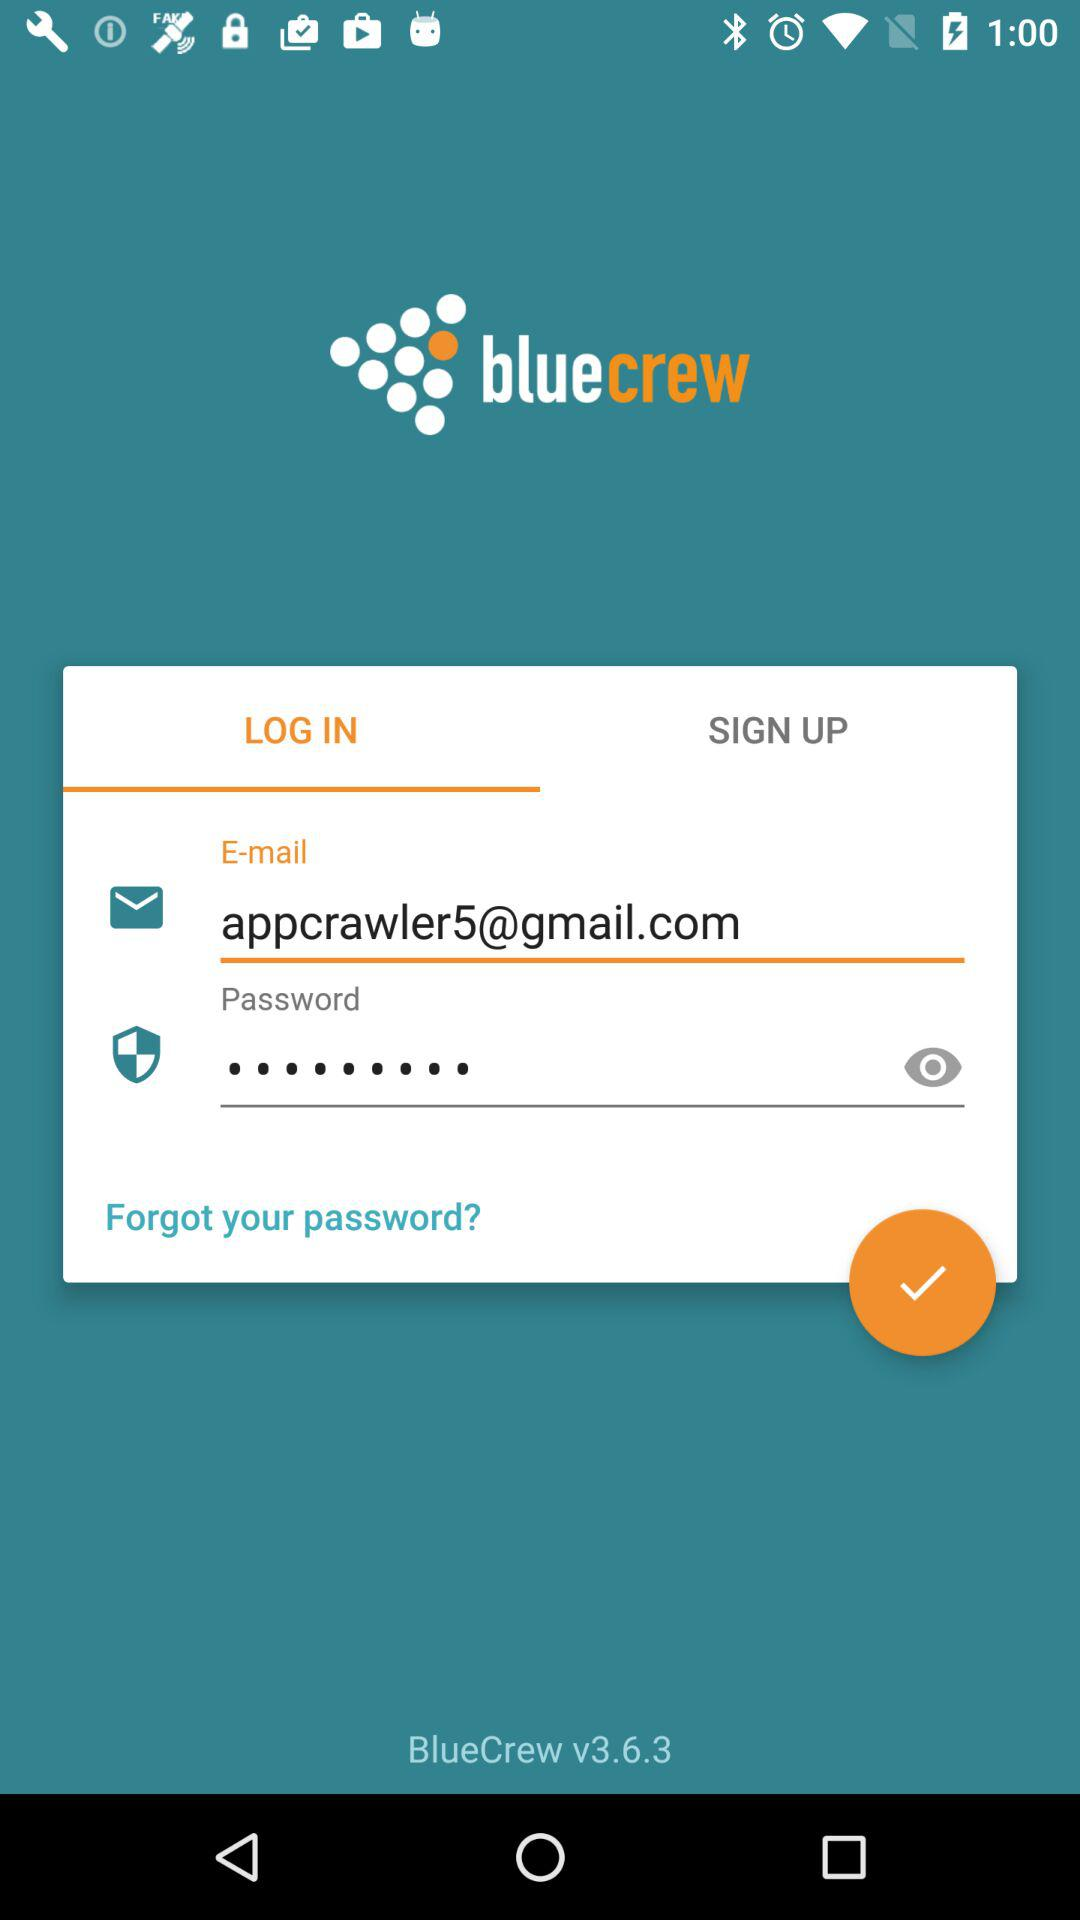What is the name of the application? The name of the application is "bluecrew". 